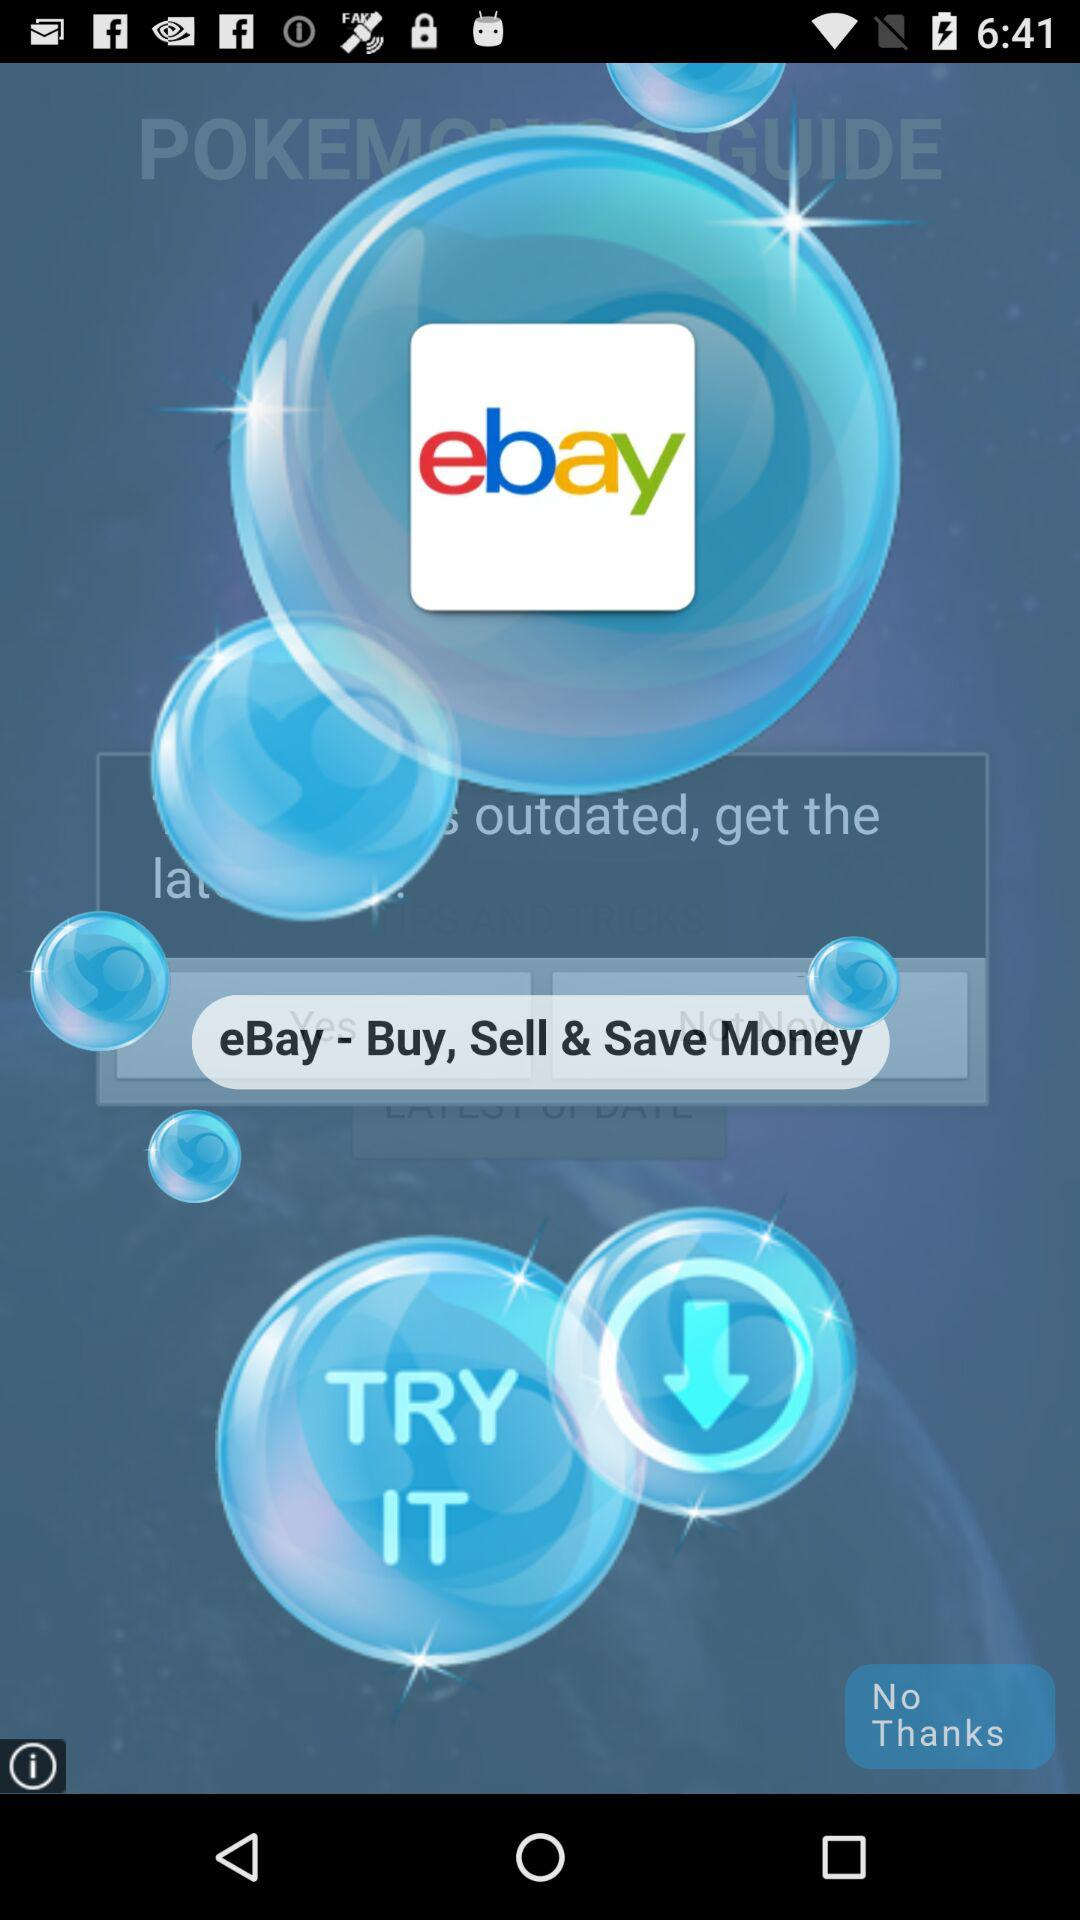What is the name of the application? The name of the application is "eBay". 